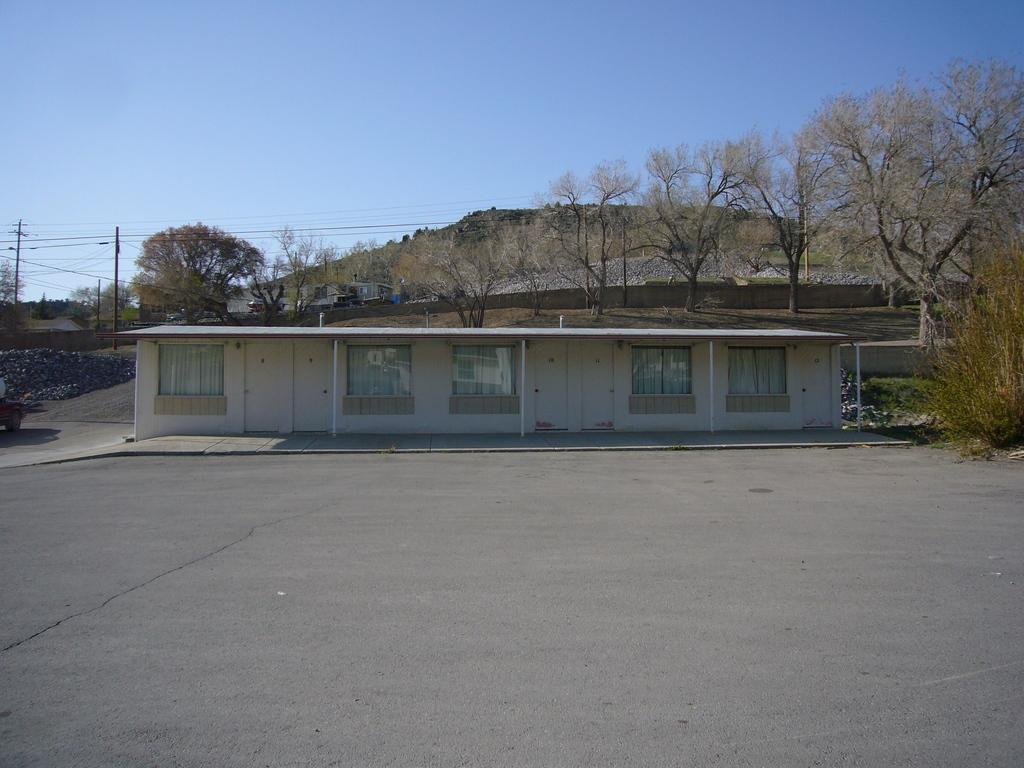How would you summarize this image in a sentence or two? This image is clicked outside. There are trees in the middle. There is a house in the middle. It has windows. There are poles on the left side. There is sky at the top. 